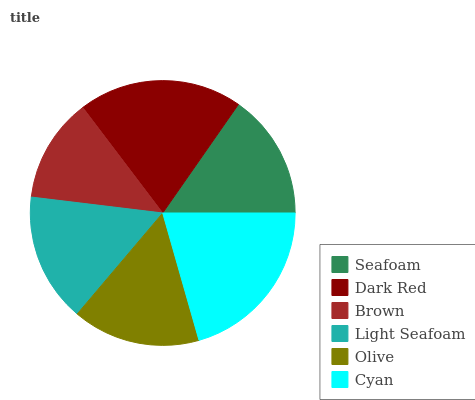Is Brown the minimum?
Answer yes or no. Yes. Is Cyan the maximum?
Answer yes or no. Yes. Is Dark Red the minimum?
Answer yes or no. No. Is Dark Red the maximum?
Answer yes or no. No. Is Dark Red greater than Seafoam?
Answer yes or no. Yes. Is Seafoam less than Dark Red?
Answer yes or no. Yes. Is Seafoam greater than Dark Red?
Answer yes or no. No. Is Dark Red less than Seafoam?
Answer yes or no. No. Is Light Seafoam the high median?
Answer yes or no. Yes. Is Olive the low median?
Answer yes or no. Yes. Is Dark Red the high median?
Answer yes or no. No. Is Dark Red the low median?
Answer yes or no. No. 